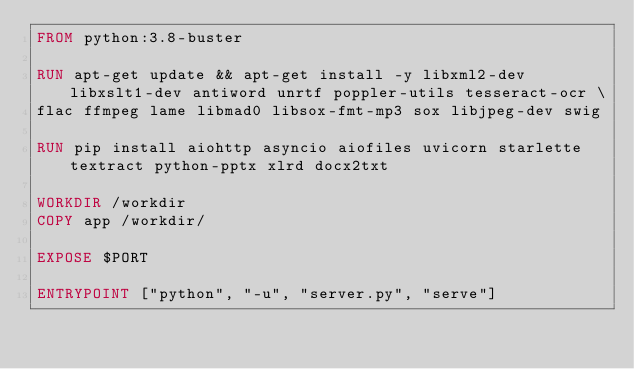<code> <loc_0><loc_0><loc_500><loc_500><_Dockerfile_>FROM python:3.8-buster

RUN apt-get update && apt-get install -y libxml2-dev libxslt1-dev antiword unrtf poppler-utils tesseract-ocr \
flac ffmpeg lame libmad0 libsox-fmt-mp3 sox libjpeg-dev swig 

RUN pip install aiohttp asyncio aiofiles uvicorn starlette textract python-pptx xlrd docx2txt

WORKDIR /workdir 
COPY app /workdir/

EXPOSE $PORT

ENTRYPOINT ["python", "-u", "server.py", "serve"]</code> 